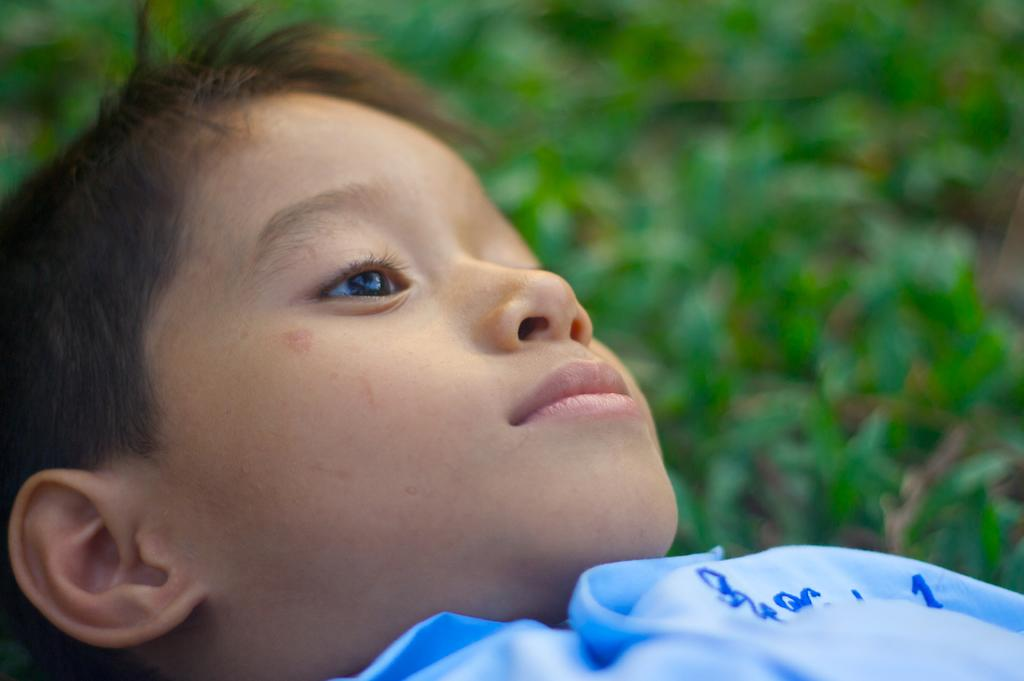What is the main subject of the image? The main subject of the image is a close-up of a child. What can be seen on the child in the image? The child is wearing clothes. What type of natural environment is visible in the image? There is grass in the foreground of the image. How would you describe the background of the image? The background of the image is blurred. What type of weather can be seen in the image? There is no indication of weather in the image, as it is a close-up of a child and does not show the sky or any other weather-related elements. 